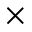<formula> <loc_0><loc_0><loc_500><loc_500>\times</formula> 